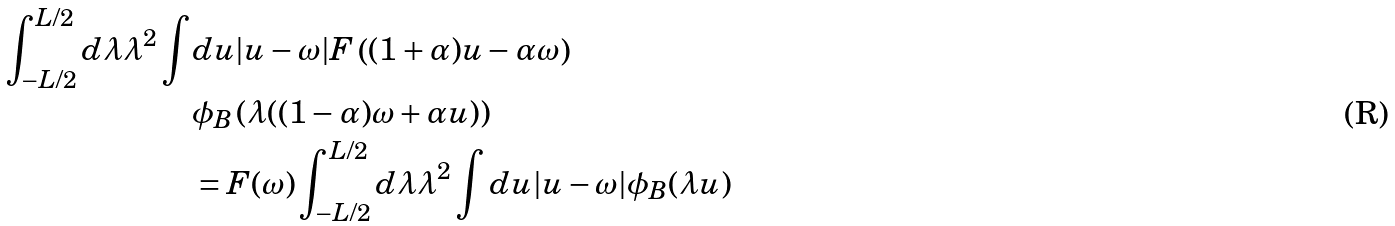<formula> <loc_0><loc_0><loc_500><loc_500>\int _ { - L / 2 } ^ { L / 2 } d \lambda \lambda ^ { 2 } \int & d u | u - \omega | F \left ( ( 1 + \alpha ) u - \alpha \omega \right ) \\ & \phi _ { B } \left ( \lambda ( ( 1 - \alpha ) \omega + \alpha u ) \right ) \\ & = F ( \omega ) \int _ { - L / 2 } ^ { L / 2 } d \lambda \lambda ^ { 2 } \int d u | u - \omega | \phi _ { B } ( \lambda u )</formula> 